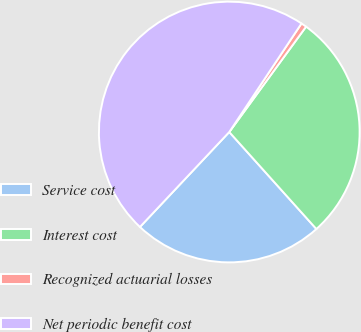<chart> <loc_0><loc_0><loc_500><loc_500><pie_chart><fcel>Service cost<fcel>Interest cost<fcel>Recognized actuarial losses<fcel>Net periodic benefit cost<nl><fcel>23.66%<fcel>28.33%<fcel>0.68%<fcel>47.33%<nl></chart> 